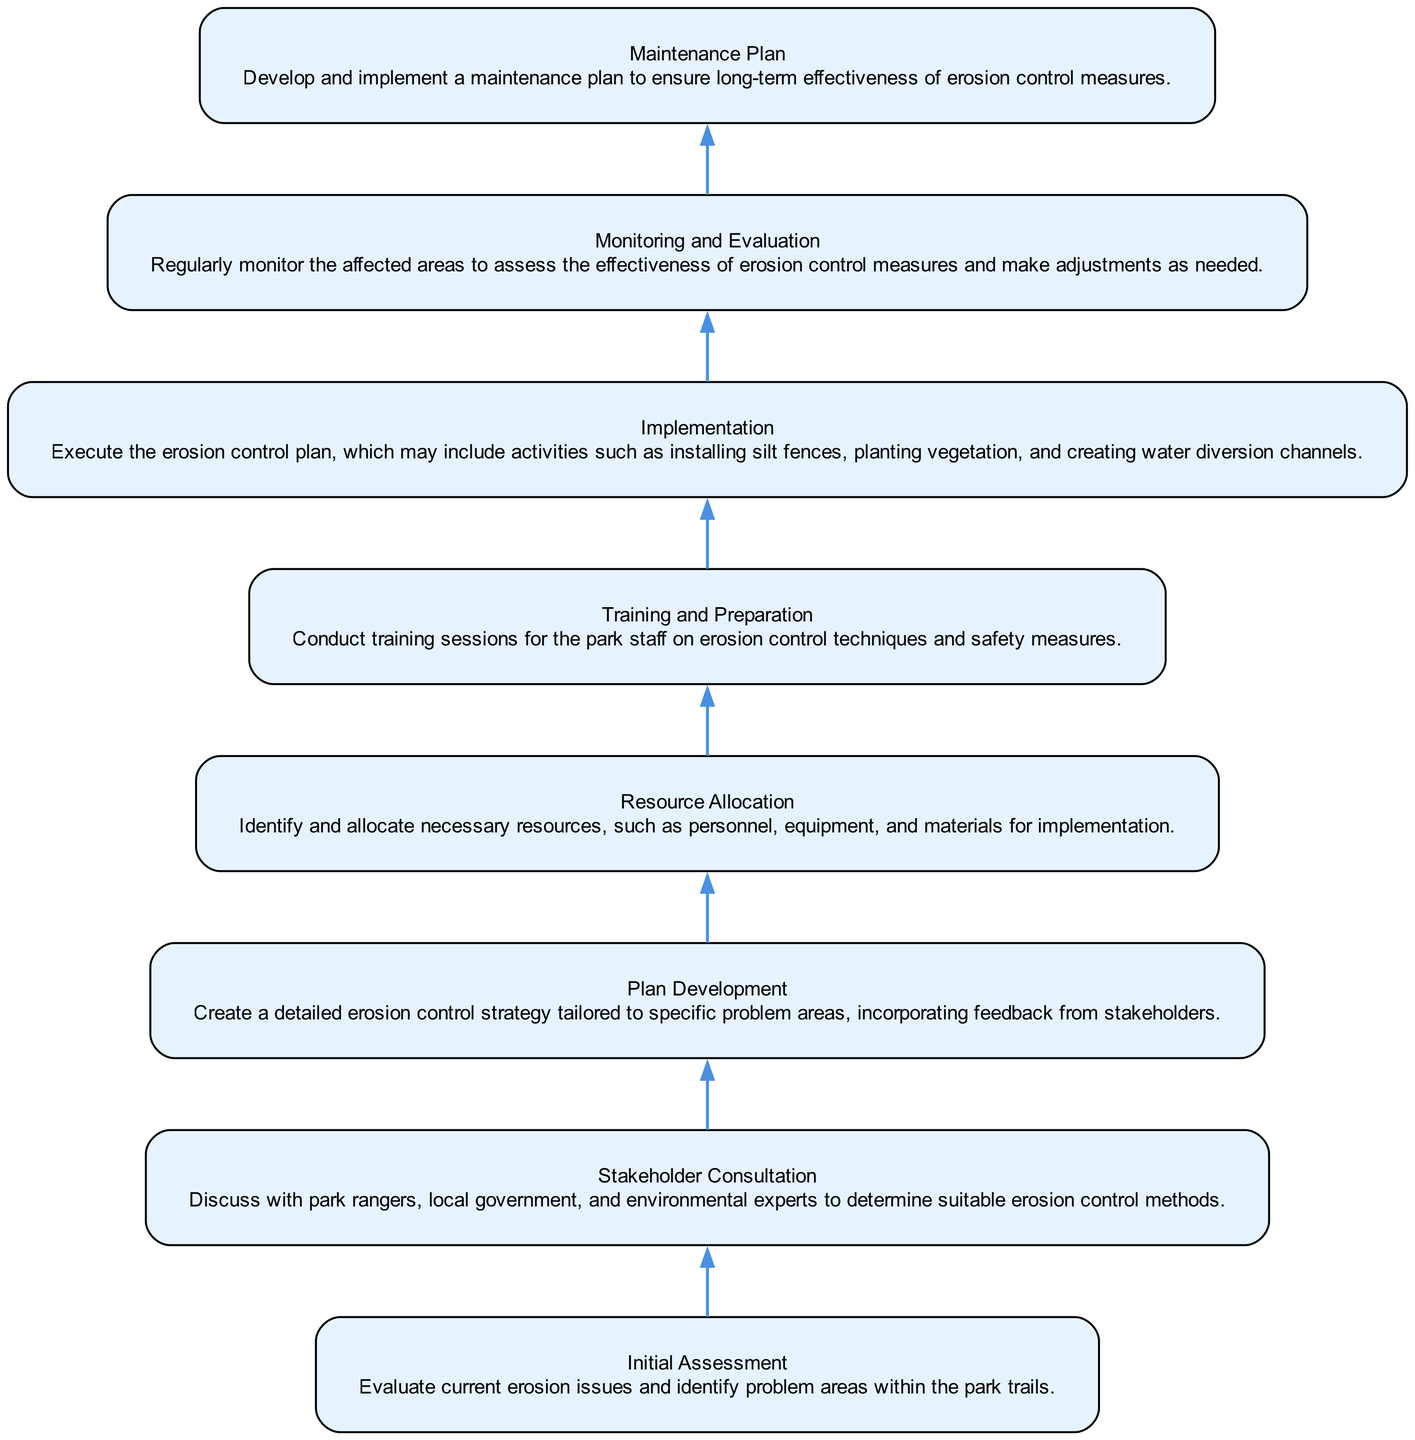What is the first step in the erosion control strategy implementation? The diagram starts with "Initial Assessment," indicating it is the first step in the process.
Answer: Initial Assessment How many total nodes are in the diagram? By counting each listed element, we see there are eight nodes representing different steps in the erosion control strategy.
Answer: 8 Which step follows "Resource Allocation"? According to the flow of the diagram, "Training and Preparation" comes directly after "Resource Allocation."
Answer: Training and Preparation What does "Implementation" involve? The description under the "Implementation" node indicates it involves executing the erosion control plan, including specific activities like installing silt fences.
Answer: Execute the erosion control plan Which two nodes are directly dependent on "Monitoring and Evaluation"? The flow indicates that the "Maintenance Plan" requires completion of "Monitoring and Evaluation," linking them directly.
Answer: Maintenance Plan What is the last step in the erosion control process? Following the flow from the bottom to the top, the last step is "Maintenance Plan," which ensures long-term effectiveness of erosion control measures.
Answer: Maintenance Plan Name one activity included in the "Implementation" phase. The description in the "Implementation" node explicitly mentions activities like planting vegetation as part of the erosion control measures.
Answer: Planting vegetation What node depends on both "Stakeholder Consultation" and "Plan Development"? Observing the nodes and their dependencies, we find that "Resource Allocation" is dependent on "Plan Development" which directly stems from "Stakeholder Consultation." However, the question is incorrect in this instance. Only "Resource Allocation" is the correct answer.
Answer: Resource Allocation 